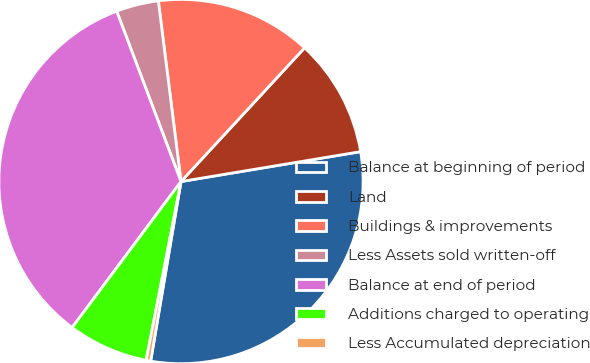Convert chart to OTSL. <chart><loc_0><loc_0><loc_500><loc_500><pie_chart><fcel>Balance at beginning of period<fcel>Land<fcel>Buildings & improvements<fcel>Less Assets sold written-off<fcel>Balance at end of period<fcel>Additions charged to operating<fcel>Less Accumulated depreciation<nl><fcel>30.29%<fcel>10.5%<fcel>13.86%<fcel>3.76%<fcel>34.06%<fcel>7.13%<fcel>0.4%<nl></chart> 